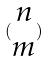Convert formula to latex. <formula><loc_0><loc_0><loc_500><loc_500>( \begin{matrix} n \\ m \end{matrix} )</formula> 